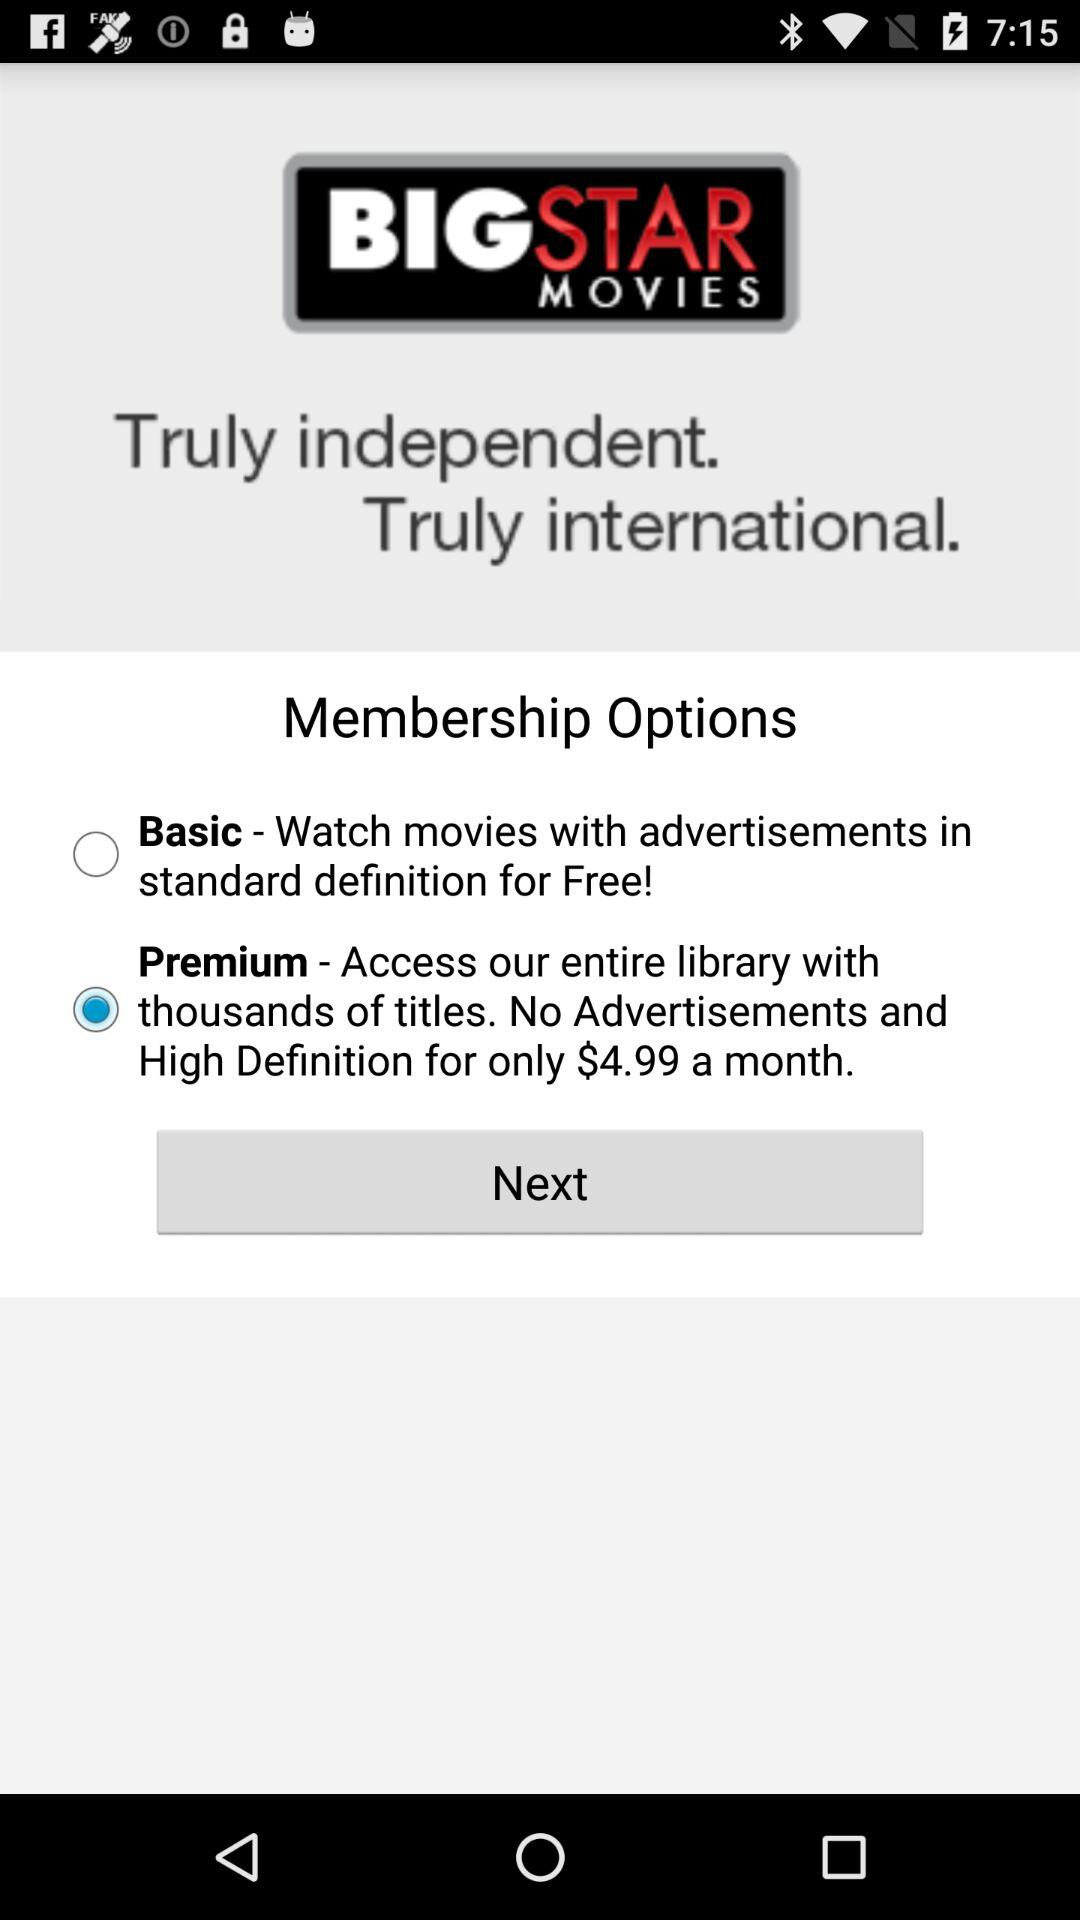Which membership option was selected? The 'Premium' membership option was chosen, as indicated by the filled radio button next to it. This option allows access to the entire library of movies without advertisements and in high definition quality, for a monthly fee of $4.99. 